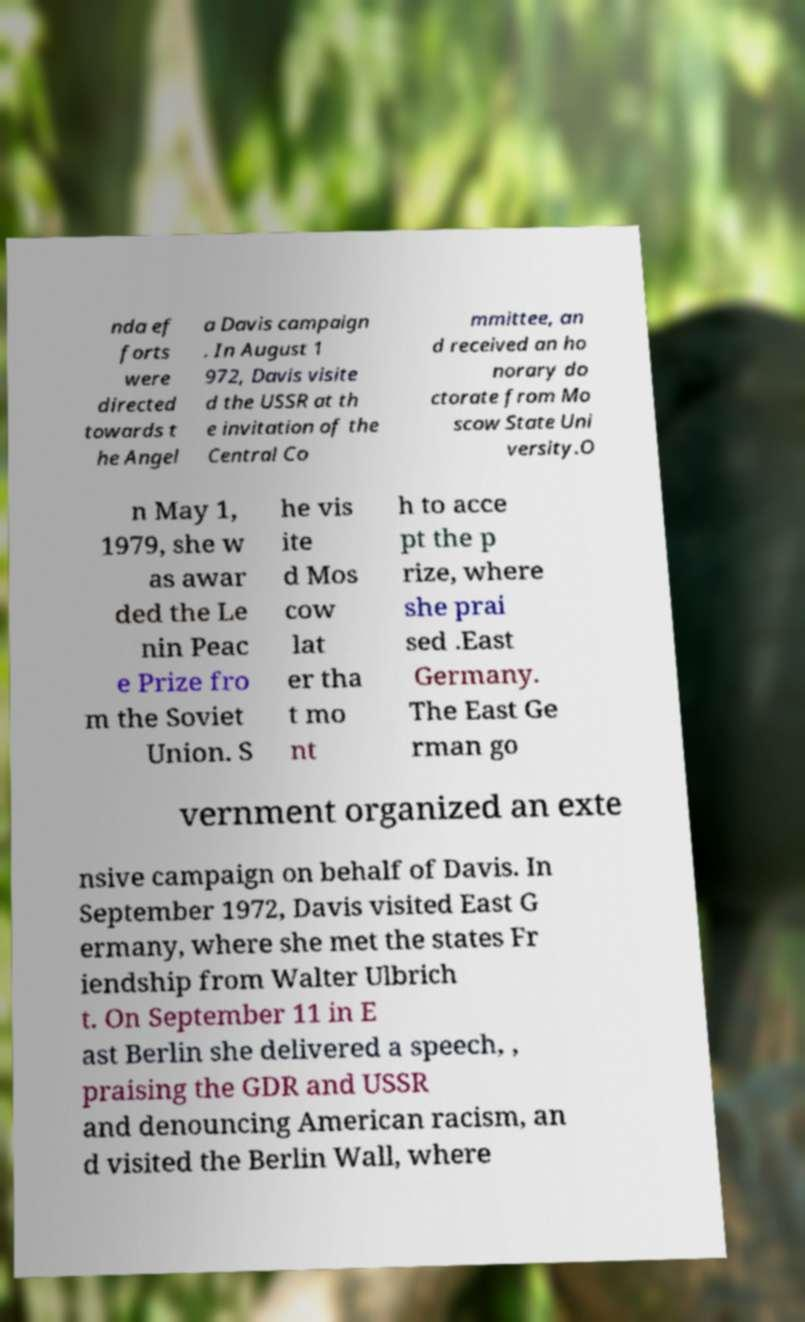Could you extract and type out the text from this image? nda ef forts were directed towards t he Angel a Davis campaign . In August 1 972, Davis visite d the USSR at th e invitation of the Central Co mmittee, an d received an ho norary do ctorate from Mo scow State Uni versity.O n May 1, 1979, she w as awar ded the Le nin Peac e Prize fro m the Soviet Union. S he vis ite d Mos cow lat er tha t mo nt h to acce pt the p rize, where she prai sed .East Germany. The East Ge rman go vernment organized an exte nsive campaign on behalf of Davis. In September 1972, Davis visited East G ermany, where she met the states Fr iendship from Walter Ulbrich t. On September 11 in E ast Berlin she delivered a speech, , praising the GDR and USSR and denouncing American racism, an d visited the Berlin Wall, where 